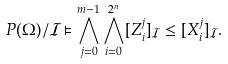Convert formula to latex. <formula><loc_0><loc_0><loc_500><loc_500>P ( \Omega ) / \mathcal { I } \vDash \bigwedge _ { j = 0 } ^ { m - 1 } \bigwedge _ { i = 0 } ^ { 2 ^ { n } } [ Z _ { i } ^ { j } ] _ { \mathcal { I } } \leq [ X _ { i } ^ { j } ] _ { \mathcal { I } } .</formula> 